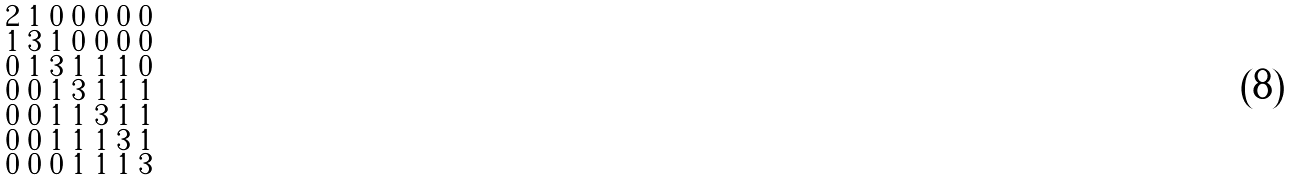Convert formula to latex. <formula><loc_0><loc_0><loc_500><loc_500>\begin{smallmatrix} 2 & 1 & 0 & 0 & 0 & 0 & 0 \\ 1 & 3 & 1 & 0 & 0 & 0 & 0 \\ 0 & 1 & 3 & 1 & 1 & 1 & 0 \\ 0 & 0 & 1 & 3 & 1 & 1 & 1 \\ 0 & 0 & 1 & 1 & 3 & 1 & 1 \\ 0 & 0 & 1 & 1 & 1 & 3 & 1 \\ 0 & 0 & 0 & 1 & 1 & 1 & 3 \end{smallmatrix}</formula> 